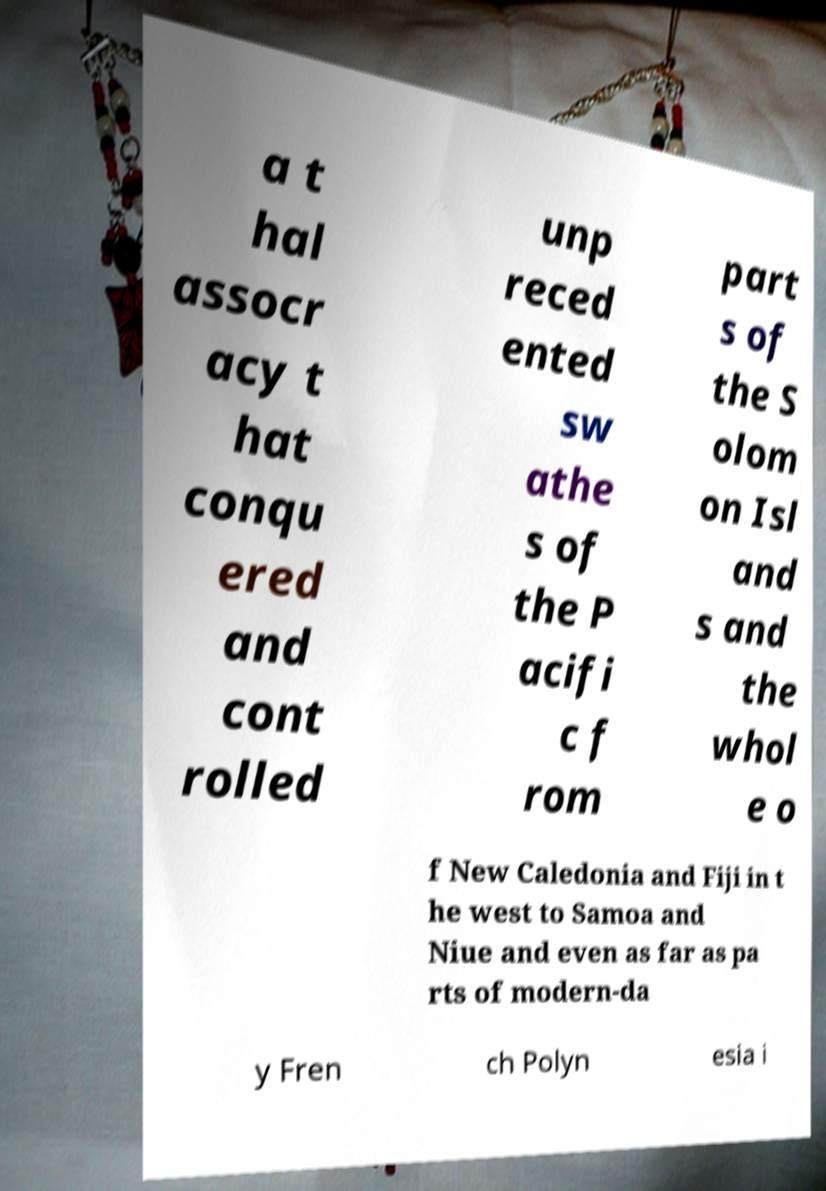Can you read and provide the text displayed in the image?This photo seems to have some interesting text. Can you extract and type it out for me? a t hal assocr acy t hat conqu ered and cont rolled unp reced ented sw athe s of the P acifi c f rom part s of the S olom on Isl and s and the whol e o f New Caledonia and Fiji in t he west to Samoa and Niue and even as far as pa rts of modern-da y Fren ch Polyn esia i 